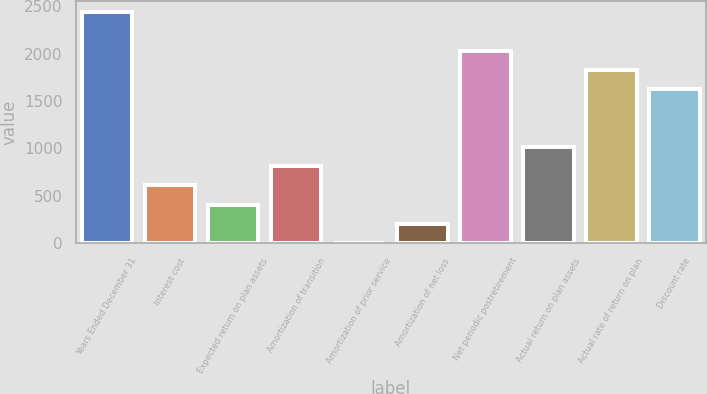Convert chart. <chart><loc_0><loc_0><loc_500><loc_500><bar_chart><fcel>Years Ended December 31<fcel>Interest cost<fcel>Expected return on plan assets<fcel>Amortization of transition<fcel>Amortization of prior service<fcel>Amortization of net loss<fcel>Net periodic postretirement<fcel>Actual return on plan assets<fcel>Actual rate of return on plan<fcel>Discount rate<nl><fcel>2435.8<fcel>609.7<fcel>406.8<fcel>812.6<fcel>1<fcel>203.9<fcel>2030<fcel>1015.5<fcel>1827.1<fcel>1624.2<nl></chart> 